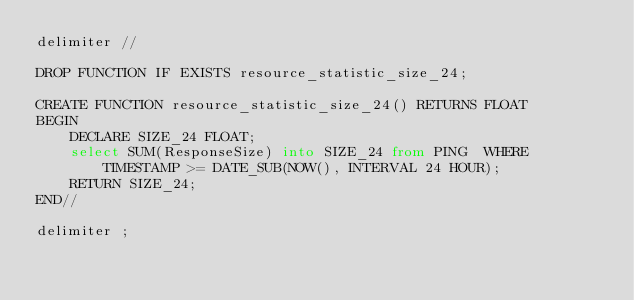Convert code to text. <code><loc_0><loc_0><loc_500><loc_500><_SQL_>delimiter //

DROP FUNCTION IF EXISTS resource_statistic_size_24;

CREATE FUNCTION resource_statistic_size_24() RETURNS FLOAT
BEGIN
    DECLARE SIZE_24 FLOAT;
    select SUM(ResponseSize) into SIZE_24 from PING  WHERE TIMESTAMP >= DATE_SUB(NOW(), INTERVAL 24 HOUR);
    RETURN SIZE_24;
END//

delimiter ;</code> 